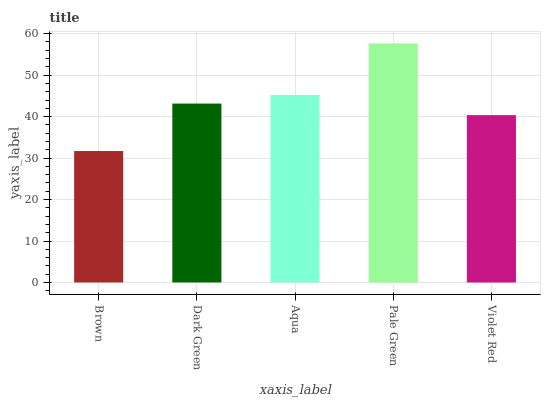Is Brown the minimum?
Answer yes or no. Yes. Is Pale Green the maximum?
Answer yes or no. Yes. Is Dark Green the minimum?
Answer yes or no. No. Is Dark Green the maximum?
Answer yes or no. No. Is Dark Green greater than Brown?
Answer yes or no. Yes. Is Brown less than Dark Green?
Answer yes or no. Yes. Is Brown greater than Dark Green?
Answer yes or no. No. Is Dark Green less than Brown?
Answer yes or no. No. Is Dark Green the high median?
Answer yes or no. Yes. Is Dark Green the low median?
Answer yes or no. Yes. Is Brown the high median?
Answer yes or no. No. Is Brown the low median?
Answer yes or no. No. 